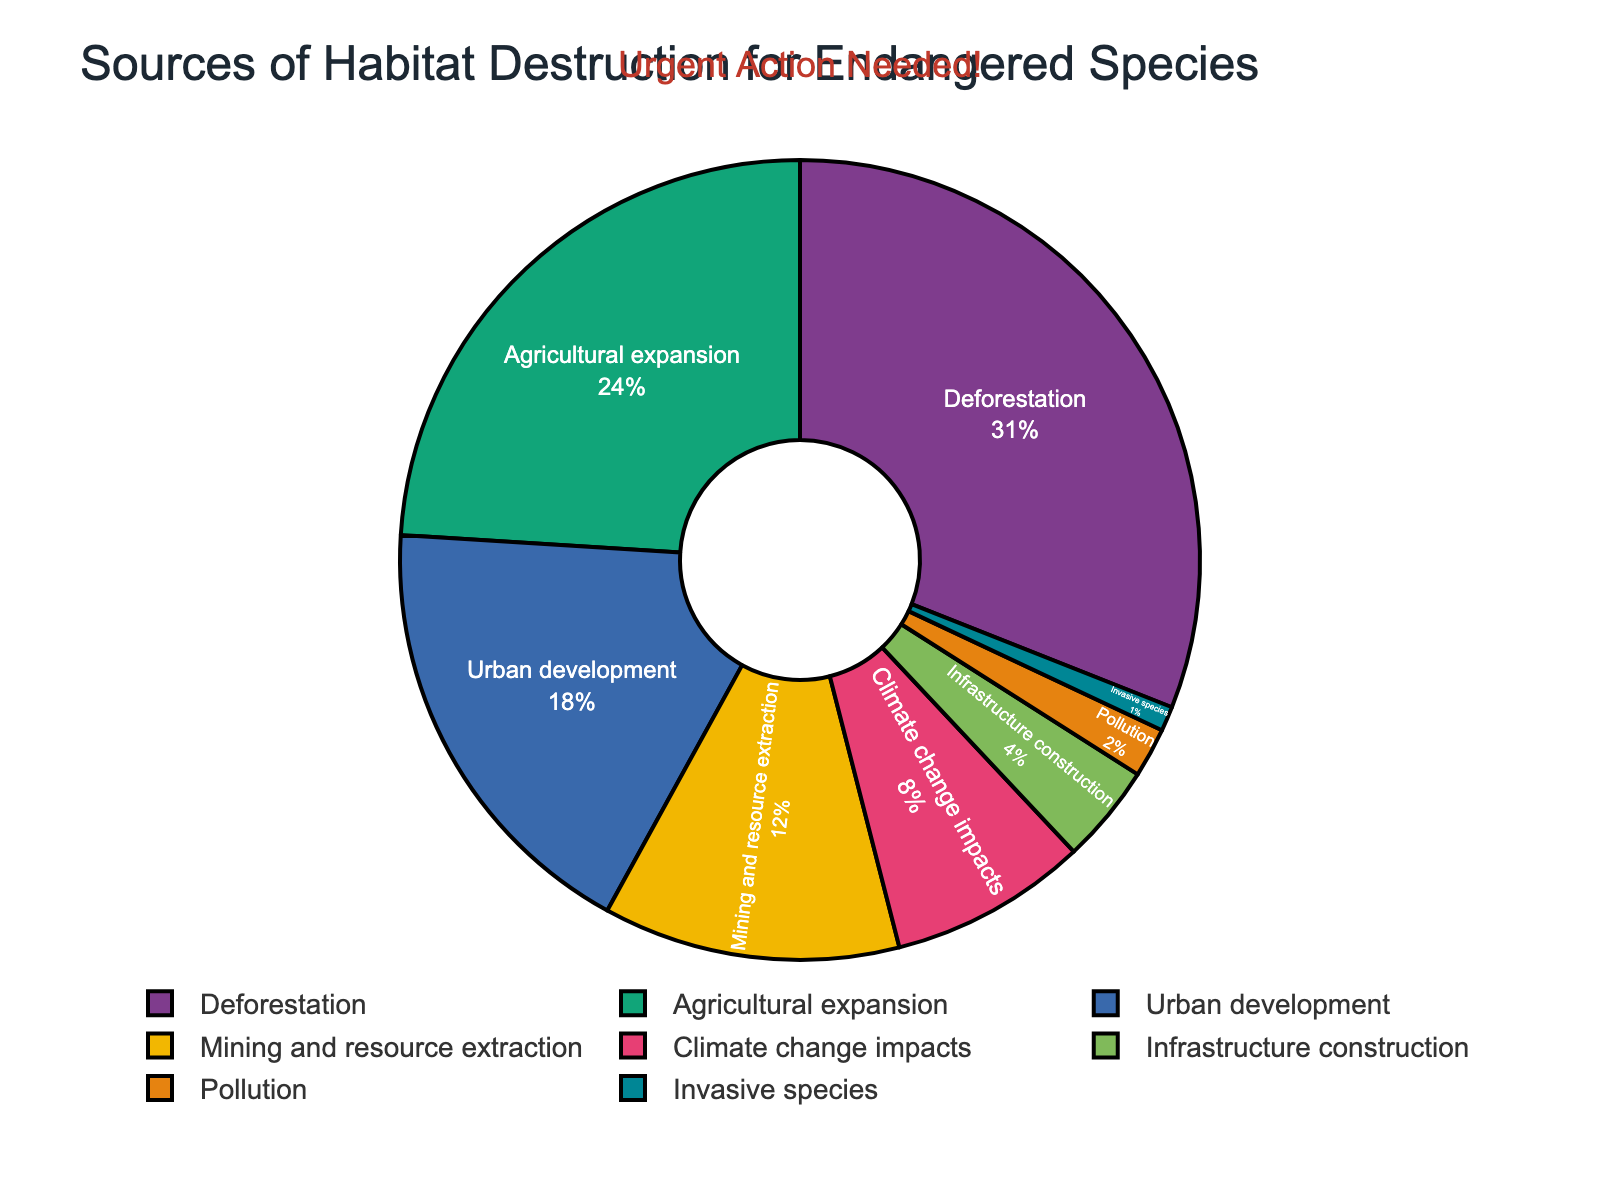What's the largest source of habitat destruction? The largest source of habitat destruction is represented by the largest slice of the pie chart. The slice labeled "Deforestation" is the largest, which indicates it is the largest source.
Answer: Deforestation What's the combined percentage of habitat destruction due to agricultural expansion and urban development? To find the combined percentage, we need to sum the percentages for agricultural expansion and urban development. Agricultural expansion is 24% and urban development is 18%, so 24% + 18% = 42%.
Answer: 42% How much greater is the impact of mining and resource extraction compared to infrastructure construction? The impact of mining and resource extraction is labeled as 12%, and infrastructure construction is labeled as 4%. Subtracting these gives 12% - 4% = 8%.
Answer: 8% Which source of habitat destruction has the smallest contribution? The smallest slice of the pie chart represents the smallest contribution to habitat destruction. This slice is labeled "Invasive species" at 1%.
Answer: Invasive species What's the total percentage of habitat destruction accounted for by climate change impacts, pollution, and invasive species? Summing up the percentages for climate change impacts (8%), pollution (2%), and invasive species (1%) gives 8% + 2% + 1% = 11%.
Answer: 11% Is the contribution of climate change impacts greater than that of mining and resource extraction? According to the pie chart, climate change impacts is 8%, whereas mining and resource extraction is 12%. Since 8% is less than 12%, climate change impacts have a smaller contribution than mining and resource extraction.
Answer: No Can the contribution of urban development and deforestation combined exceed 50%? Urban development contributes 18% and deforestation contributes 31%. Adding these two gives 18% + 31% = 49%, which does not exceed 50%.
Answer: No Which sectors contribute more than 20% to habitat destruction? The pie chart's labels show that only "Deforestation" (31%) and "Agricultural expansion" (24%) have contributions greater than 20%.
Answer: Deforestation and Agricultural expansion 